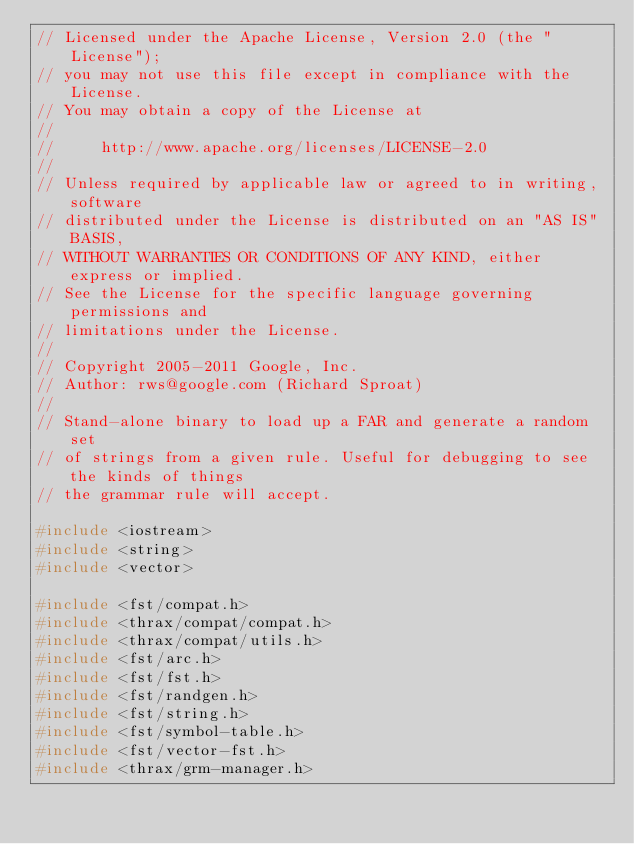Convert code to text. <code><loc_0><loc_0><loc_500><loc_500><_C++_>// Licensed under the Apache License, Version 2.0 (the "License");
// you may not use this file except in compliance with the License.
// You may obtain a copy of the License at
//
//     http://www.apache.org/licenses/LICENSE-2.0
//
// Unless required by applicable law or agreed to in writing, software
// distributed under the License is distributed on an "AS IS" BASIS,
// WITHOUT WARRANTIES OR CONDITIONS OF ANY KIND, either express or implied.
// See the License for the specific language governing permissions and
// limitations under the License.
//
// Copyright 2005-2011 Google, Inc.
// Author: rws@google.com (Richard Sproat)
//
// Stand-alone binary to load up a FAR and generate a random set
// of strings from a given rule. Useful for debugging to see the kinds of things
// the grammar rule will accept.

#include <iostream>
#include <string>
#include <vector>

#include <fst/compat.h>
#include <thrax/compat/compat.h>
#include <thrax/compat/utils.h>
#include <fst/arc.h>
#include <fst/fst.h>
#include <fst/randgen.h>
#include <fst/string.h>
#include <fst/symbol-table.h>
#include <fst/vector-fst.h>
#include <thrax/grm-manager.h></code> 